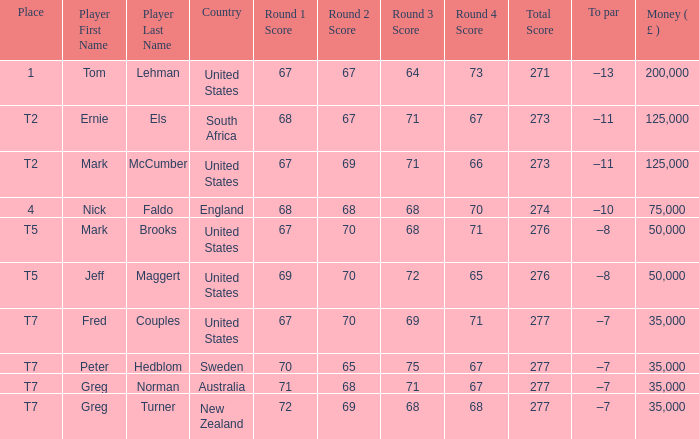What is To par, when Country is "United States", when Money ( £ ) is greater than 125,000, and when Score is "67-70-68-71=276"? None. 